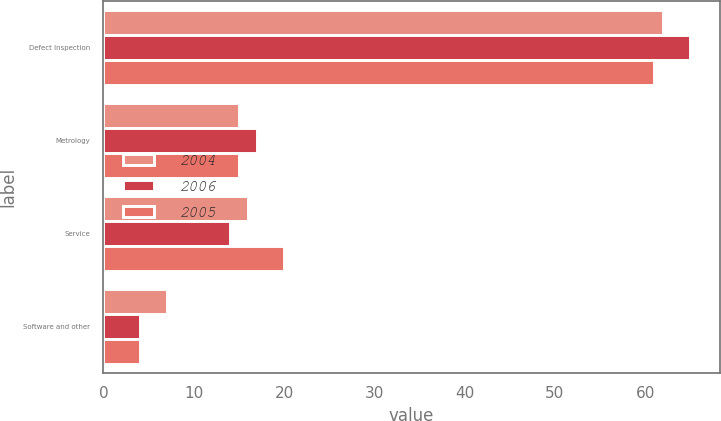Convert chart to OTSL. <chart><loc_0><loc_0><loc_500><loc_500><stacked_bar_chart><ecel><fcel>Defect Inspection<fcel>Metrology<fcel>Service<fcel>Software and other<nl><fcel>2004<fcel>62<fcel>15<fcel>16<fcel>7<nl><fcel>2006<fcel>65<fcel>17<fcel>14<fcel>4<nl><fcel>2005<fcel>61<fcel>15<fcel>20<fcel>4<nl></chart> 